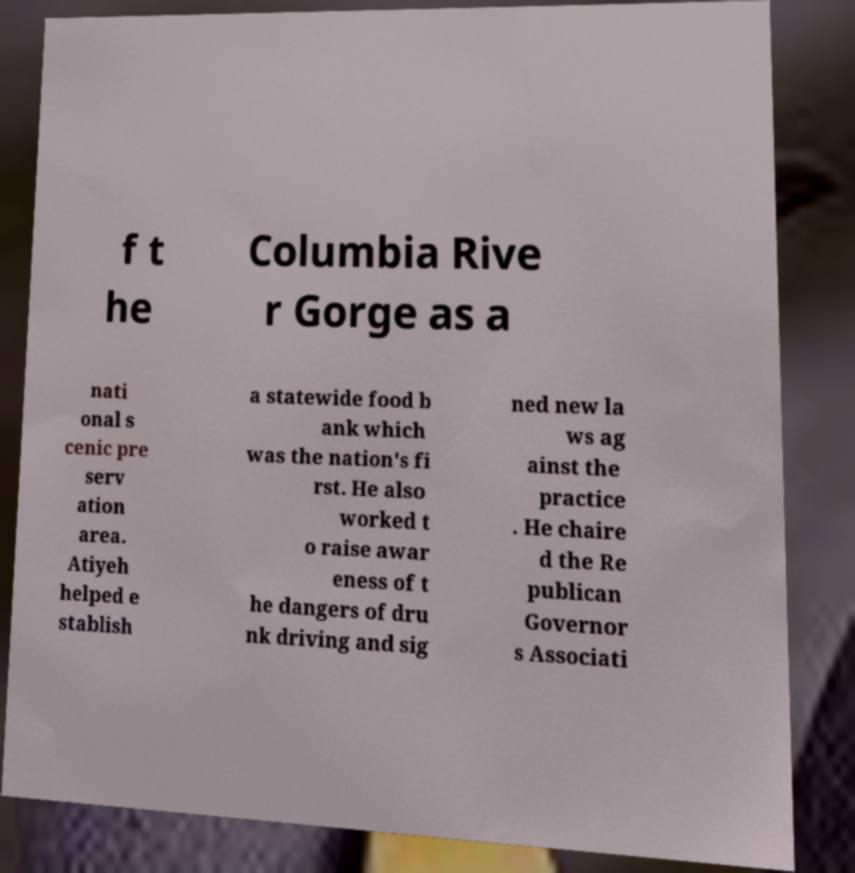Please read and relay the text visible in this image. What does it say? f t he Columbia Rive r Gorge as a nati onal s cenic pre serv ation area. Atiyeh helped e stablish a statewide food b ank which was the nation's fi rst. He also worked t o raise awar eness of t he dangers of dru nk driving and sig ned new la ws ag ainst the practice . He chaire d the Re publican Governor s Associati 